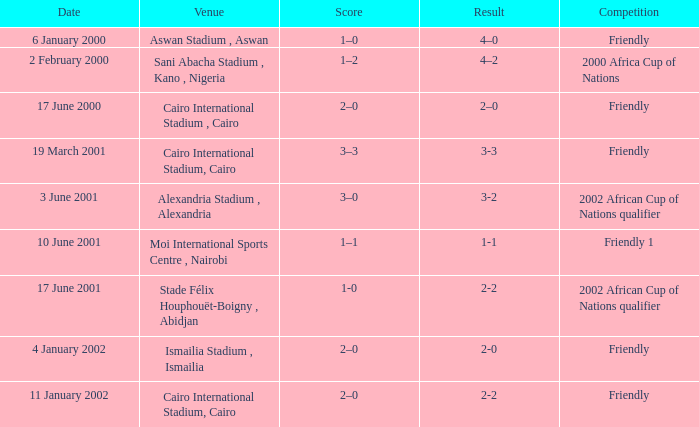What is the score of the match with a 3-2 result? 3–0. 